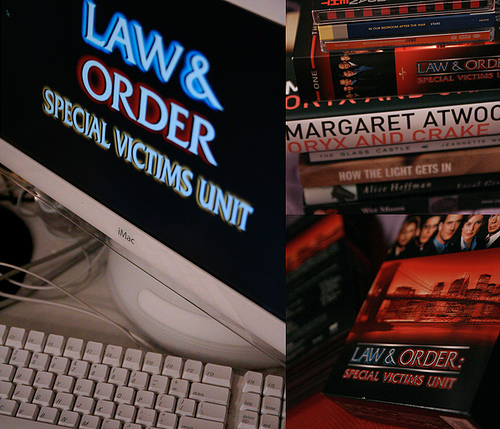Identify the text contained in this image. ORDER LAW SPECIAL VICTIMS UNIT SPECIAL VICTIMS UNIT ORDER &amp; LAW IN CETS LIGHT THE HOW ORYX AND CRAKE ATWOO MARGARET SPLCIAL VICYINGS ORD &amp; LAW ONE iMac 